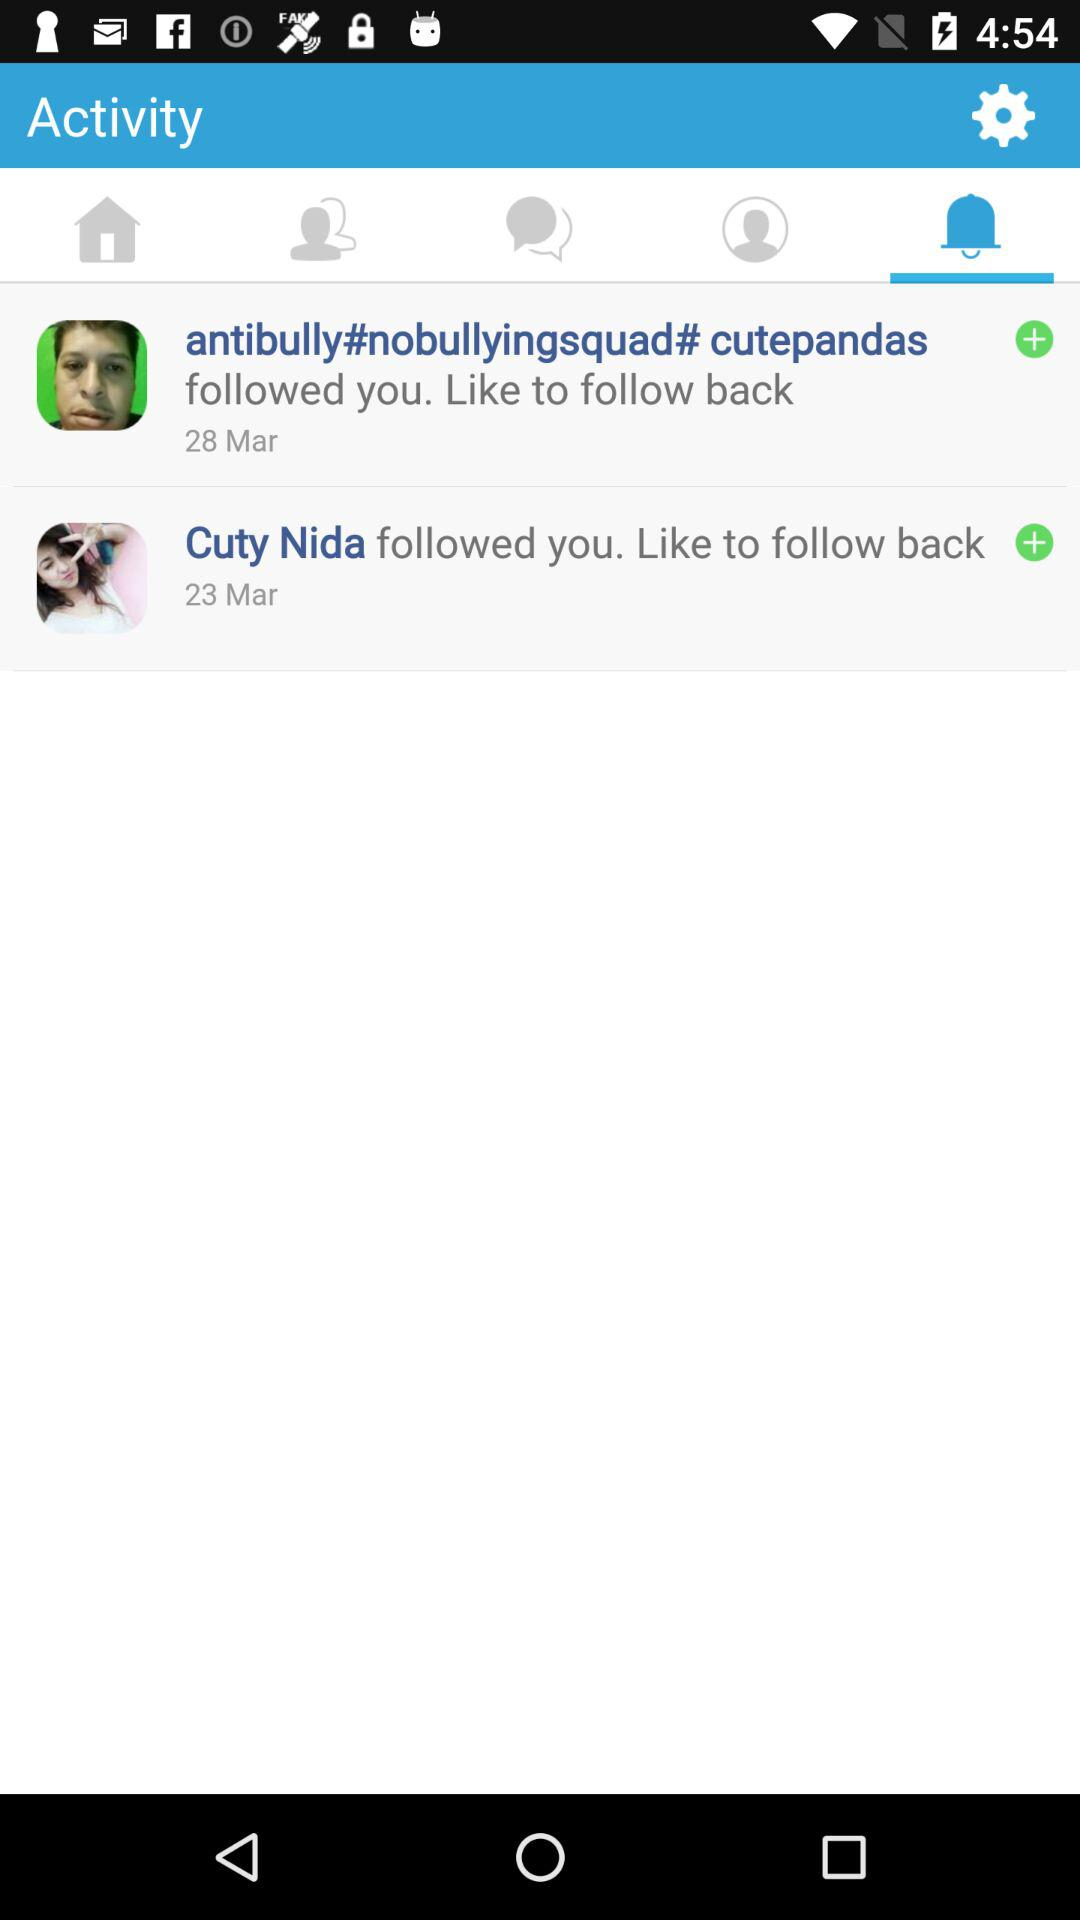How many people followed you in total?
Answer the question using a single word or phrase. 2 